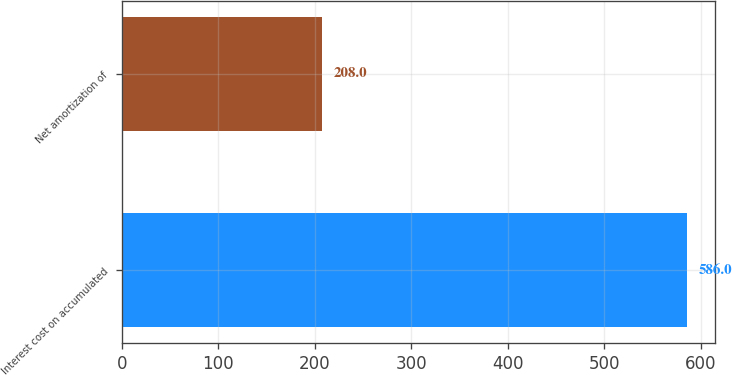Convert chart to OTSL. <chart><loc_0><loc_0><loc_500><loc_500><bar_chart><fcel>Interest cost on accumulated<fcel>Net amortization of<nl><fcel>586<fcel>208<nl></chart> 